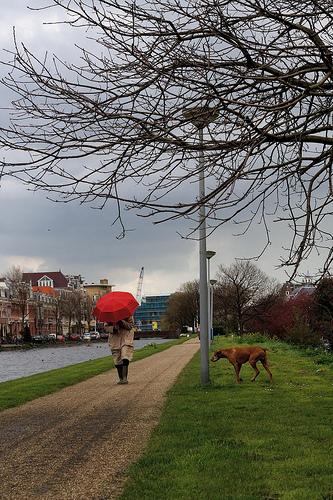Will the umbrella get caught in the tree?
Give a very brief answer. No. What color is the person's coat?
Concise answer only. Tan. Is the person standing on grass?
Keep it brief. No. What is in the tree?
Quick response, please. Branches. Is the dog in the foreground leaping?
Quick response, please. No. Is this good weather to fly a kite?
Concise answer only. No. What color is the sidewalk?
Quick response, please. Brown. Is the path paved?
Write a very short answer. No. What is the dog chasing?
Be succinct. Man. Is it raining?
Write a very short answer. Yes. 